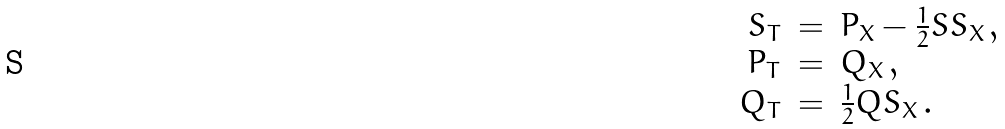<formula> <loc_0><loc_0><loc_500><loc_500>\begin{array} { r c l } S _ { T } & = & P _ { X } - \frac { 1 } { 2 } S S _ { X } \, , \\ P _ { T } & = & Q _ { X } \, , \\ Q _ { T } & = & \frac { 1 } { 2 } Q S _ { X } \, . \end{array}</formula> 